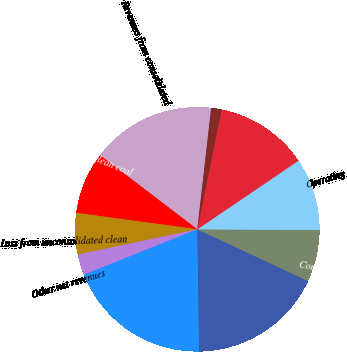<chart> <loc_0><loc_0><loc_500><loc_500><pie_chart><fcel>Revenues from consolidated<fcel>Royalty income from clean coal<fcel>Loss from unconsolidated clean<fcel>Other net revenues<fcel>Total revenues<fcel>Cost of revenues from<fcel>Compens ation<fcel>Operating<fcel>Interest<fcel>Depreciation<nl><fcel>16.44%<fcel>8.22%<fcel>5.48%<fcel>2.74%<fcel>19.18%<fcel>17.81%<fcel>6.85%<fcel>9.59%<fcel>12.33%<fcel>1.37%<nl></chart> 